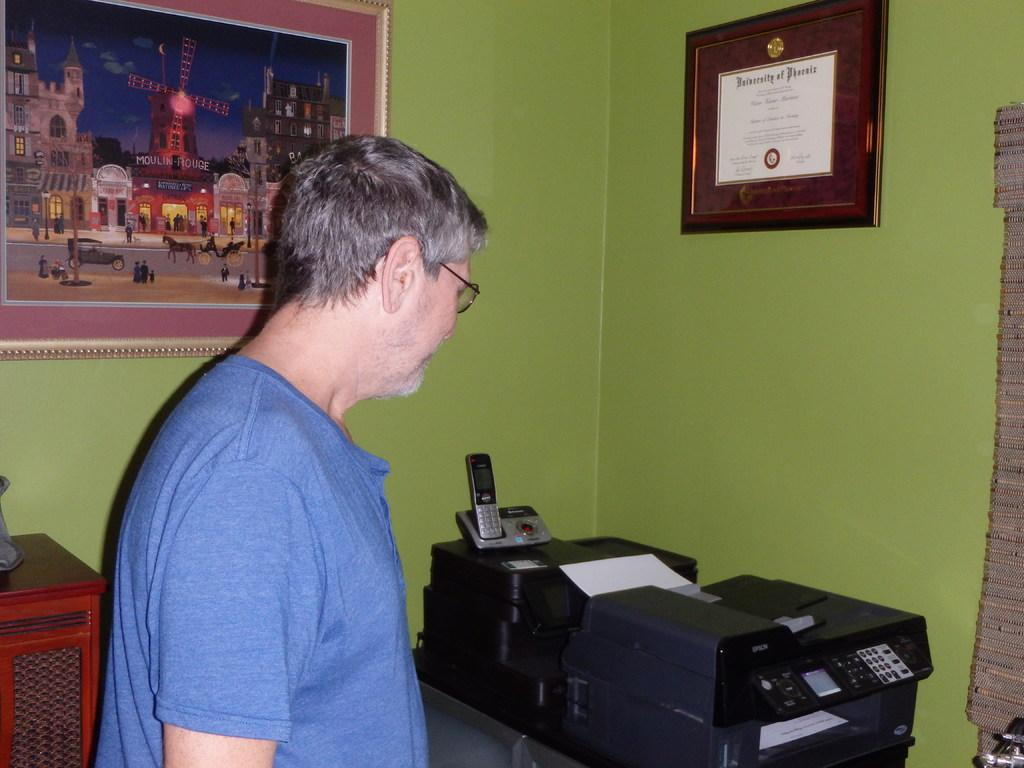<image>
Describe the image concisely. A man stands underneath a University of Phoenix degree. 